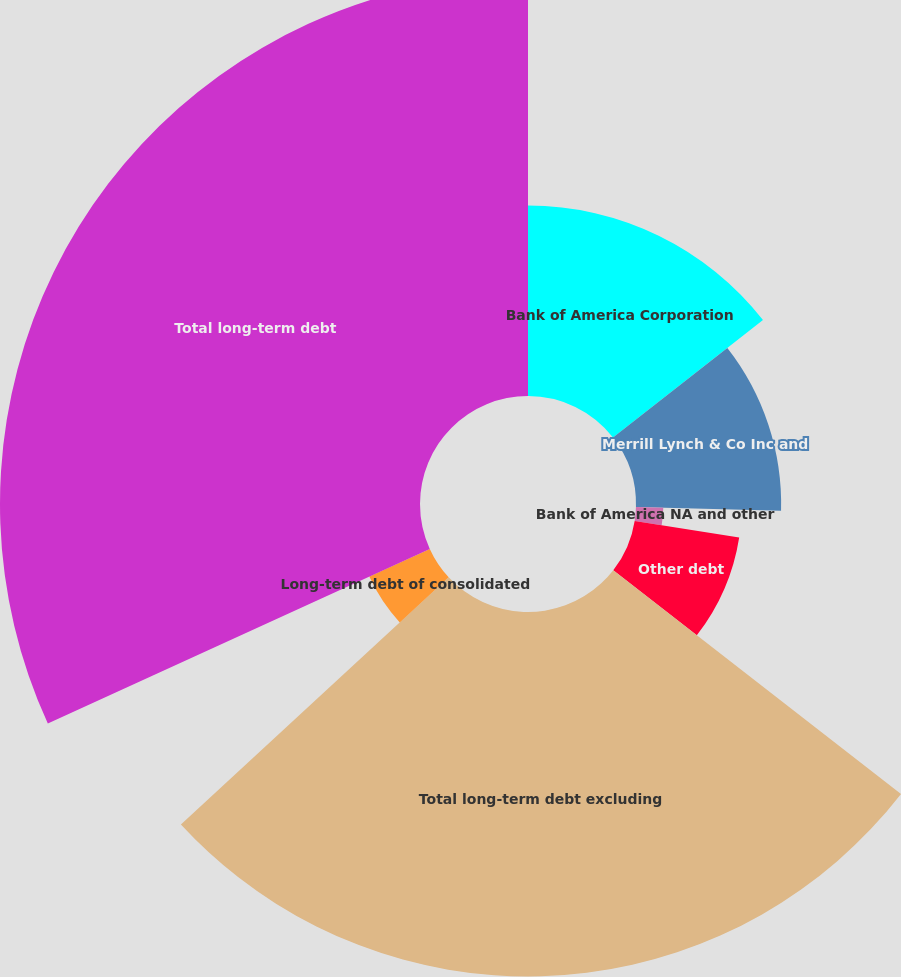Convert chart. <chart><loc_0><loc_0><loc_500><loc_500><pie_chart><fcel>Bank of America Corporation<fcel>Merrill Lynch & Co Inc and<fcel>Bank of America NA and other<fcel>Other debt<fcel>Total long-term debt excluding<fcel>Long-term debt of consolidated<fcel>Total long-term debt<nl><fcel>14.43%<fcel>11.0%<fcel>2.07%<fcel>8.02%<fcel>27.62%<fcel>5.04%<fcel>31.83%<nl></chart> 